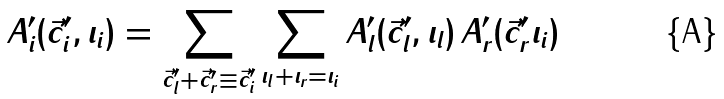<formula> <loc_0><loc_0><loc_500><loc_500>A _ { i } ^ { \prime } ( \vec { c } _ { i } ^ { \prime } , \iota _ { i } ) = \sum _ { \vec { c } _ { l } ^ { \prime } + \vec { c } _ { r } ^ { \prime } \equiv \vec { c } _ { i } ^ { \prime } } \sum _ { \iota _ { l } + \iota _ { r } = \iota _ { i } } A _ { l } ^ { \prime } ( \vec { c } _ { l } ^ { \prime } , \iota _ { l } ) \, A _ { r } ^ { \prime } ( \vec { c } _ { r } ^ { \prime } \iota _ { i } )</formula> 